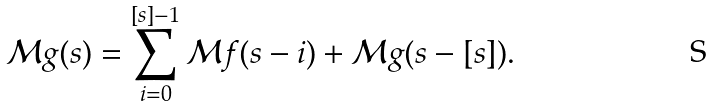Convert formula to latex. <formula><loc_0><loc_0><loc_500><loc_500>\mathcal { M } g ( s ) = \sum _ { i = 0 } ^ { [ s ] - 1 } \mathcal { M } f ( s - i ) + \mathcal { M } g ( s - [ s ] ) .</formula> 